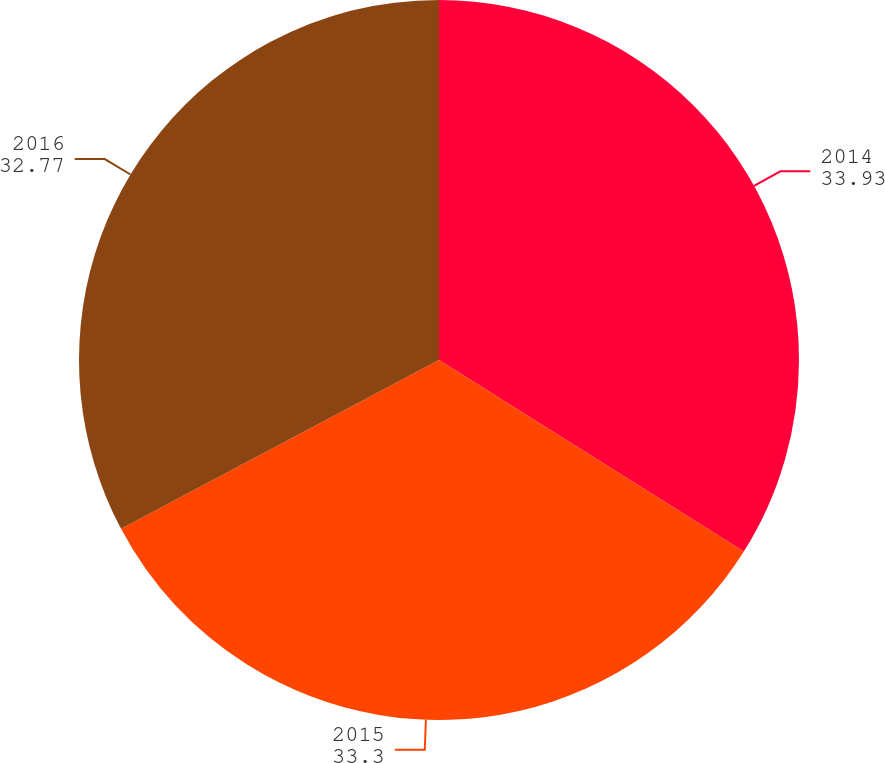Convert chart to OTSL. <chart><loc_0><loc_0><loc_500><loc_500><pie_chart><fcel>2014<fcel>2015<fcel>2016<nl><fcel>33.93%<fcel>33.3%<fcel>32.77%<nl></chart> 